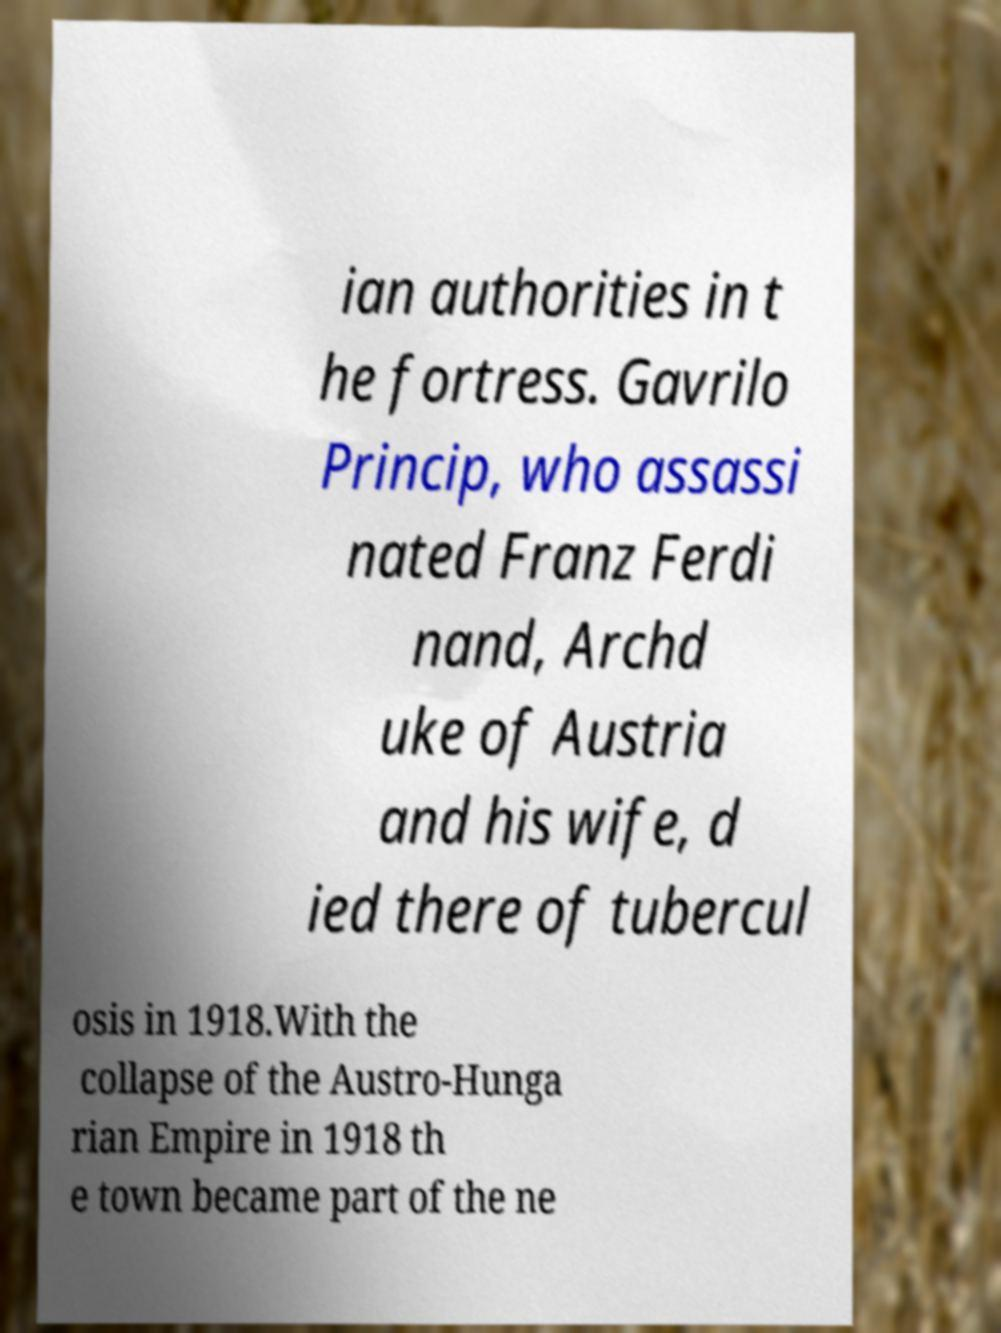For documentation purposes, I need the text within this image transcribed. Could you provide that? ian authorities in t he fortress. Gavrilo Princip, who assassi nated Franz Ferdi nand, Archd uke of Austria and his wife, d ied there of tubercul osis in 1918.With the collapse of the Austro-Hunga rian Empire in 1918 th e town became part of the ne 